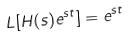<formula> <loc_0><loc_0><loc_500><loc_500>L [ H ( s ) e ^ { s t } ] = e ^ { s t }</formula> 